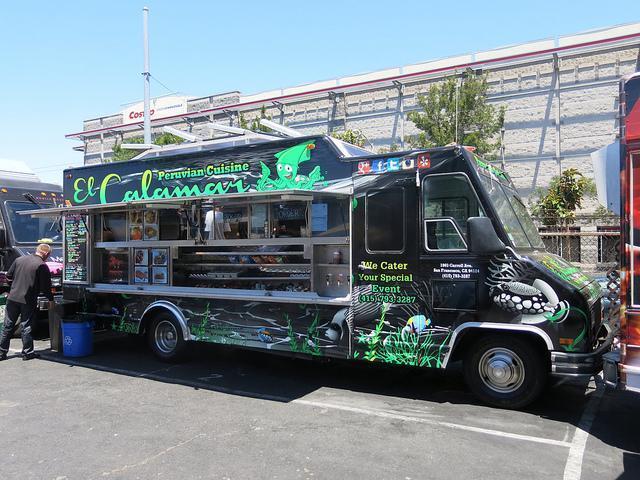How many bears are licking their paws?
Give a very brief answer. 0. 